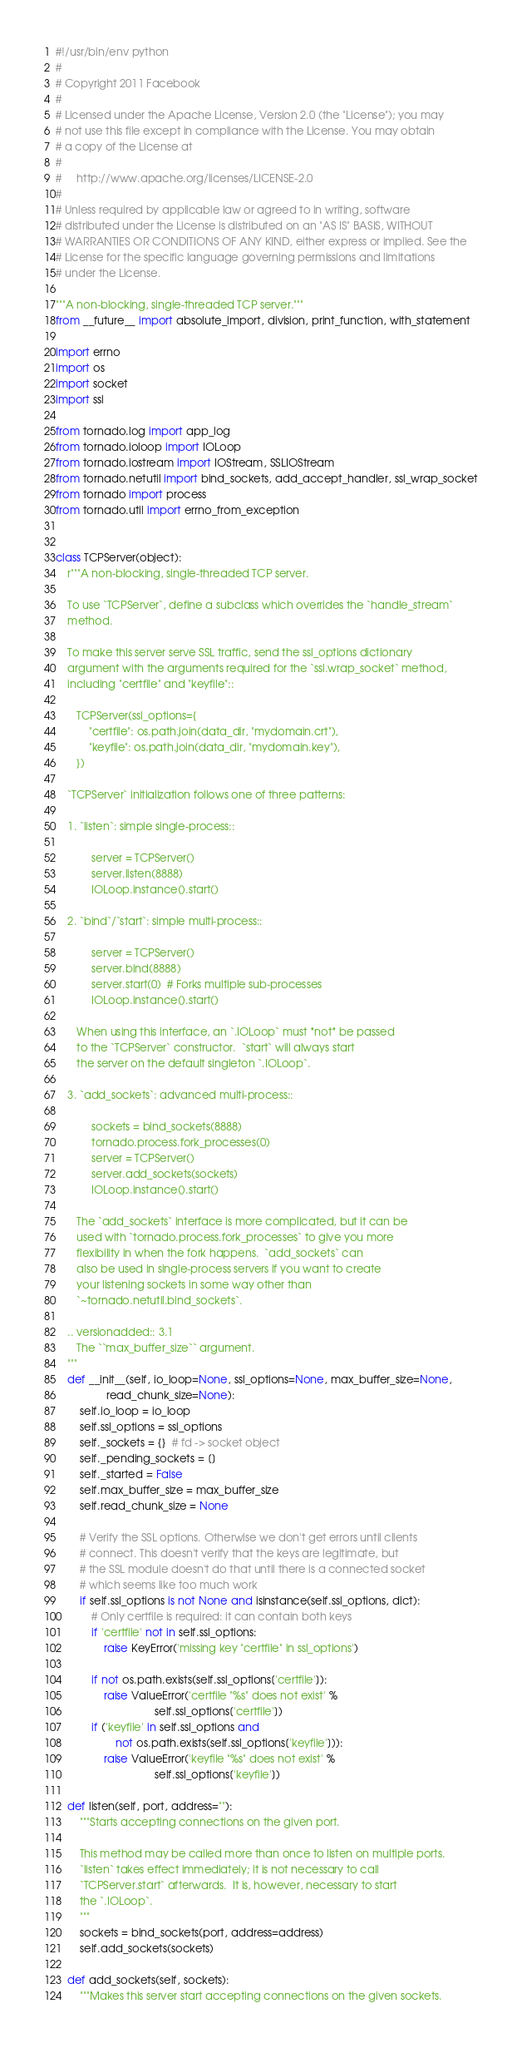<code> <loc_0><loc_0><loc_500><loc_500><_Python_>#!/usr/bin/env python
#
# Copyright 2011 Facebook
#
# Licensed under the Apache License, Version 2.0 (the "License"); you may
# not use this file except in compliance with the License. You may obtain
# a copy of the License at
#
#     http://www.apache.org/licenses/LICENSE-2.0
#
# Unless required by applicable law or agreed to in writing, software
# distributed under the License is distributed on an "AS IS" BASIS, WITHOUT
# WARRANTIES OR CONDITIONS OF ANY KIND, either express or implied. See the
# License for the specific language governing permissions and limitations
# under the License.

"""A non-blocking, single-threaded TCP server."""
from __future__ import absolute_import, division, print_function, with_statement

import errno
import os
import socket
import ssl

from tornado.log import app_log
from tornado.ioloop import IOLoop
from tornado.iostream import IOStream, SSLIOStream
from tornado.netutil import bind_sockets, add_accept_handler, ssl_wrap_socket
from tornado import process
from tornado.util import errno_from_exception


class TCPServer(object):
    r"""A non-blocking, single-threaded TCP server.

    To use `TCPServer`, define a subclass which overrides the `handle_stream`
    method.

    To make this server serve SSL traffic, send the ssl_options dictionary
    argument with the arguments required for the `ssl.wrap_socket` method,
    including "certfile" and "keyfile"::

       TCPServer(ssl_options={
           "certfile": os.path.join(data_dir, "mydomain.crt"),
           "keyfile": os.path.join(data_dir, "mydomain.key"),
       })

    `TCPServer` initialization follows one of three patterns:

    1. `listen`: simple single-process::

            server = TCPServer()
            server.listen(8888)
            IOLoop.instance().start()

    2. `bind`/`start`: simple multi-process::

            server = TCPServer()
            server.bind(8888)
            server.start(0)  # Forks multiple sub-processes
            IOLoop.instance().start()

       When using this interface, an `.IOLoop` must *not* be passed
       to the `TCPServer` constructor.  `start` will always start
       the server on the default singleton `.IOLoop`.

    3. `add_sockets`: advanced multi-process::

            sockets = bind_sockets(8888)
            tornado.process.fork_processes(0)
            server = TCPServer()
            server.add_sockets(sockets)
            IOLoop.instance().start()

       The `add_sockets` interface is more complicated, but it can be
       used with `tornado.process.fork_processes` to give you more
       flexibility in when the fork happens.  `add_sockets` can
       also be used in single-process servers if you want to create
       your listening sockets in some way other than
       `~tornado.netutil.bind_sockets`.

    .. versionadded:: 3.1
       The ``max_buffer_size`` argument.
    """
    def __init__(self, io_loop=None, ssl_options=None, max_buffer_size=None,
                 read_chunk_size=None):
        self.io_loop = io_loop
        self.ssl_options = ssl_options
        self._sockets = {}  # fd -> socket object
        self._pending_sockets = []
        self._started = False
        self.max_buffer_size = max_buffer_size
        self.read_chunk_size = None

        # Verify the SSL options. Otherwise we don't get errors until clients
        # connect. This doesn't verify that the keys are legitimate, but
        # the SSL module doesn't do that until there is a connected socket
        # which seems like too much work
        if self.ssl_options is not None and isinstance(self.ssl_options, dict):
            # Only certfile is required: it can contain both keys
            if 'certfile' not in self.ssl_options:
                raise KeyError('missing key "certfile" in ssl_options')

            if not os.path.exists(self.ssl_options['certfile']):
                raise ValueError('certfile "%s" does not exist' %
                                 self.ssl_options['certfile'])
            if ('keyfile' in self.ssl_options and
                    not os.path.exists(self.ssl_options['keyfile'])):
                raise ValueError('keyfile "%s" does not exist' %
                                 self.ssl_options['keyfile'])

    def listen(self, port, address=""):
        """Starts accepting connections on the given port.

        This method may be called more than once to listen on multiple ports.
        `listen` takes effect immediately; it is not necessary to call
        `TCPServer.start` afterwards.  It is, however, necessary to start
        the `.IOLoop`.
        """
        sockets = bind_sockets(port, address=address)
        self.add_sockets(sockets)

    def add_sockets(self, sockets):
        """Makes this server start accepting connections on the given sockets.
</code> 